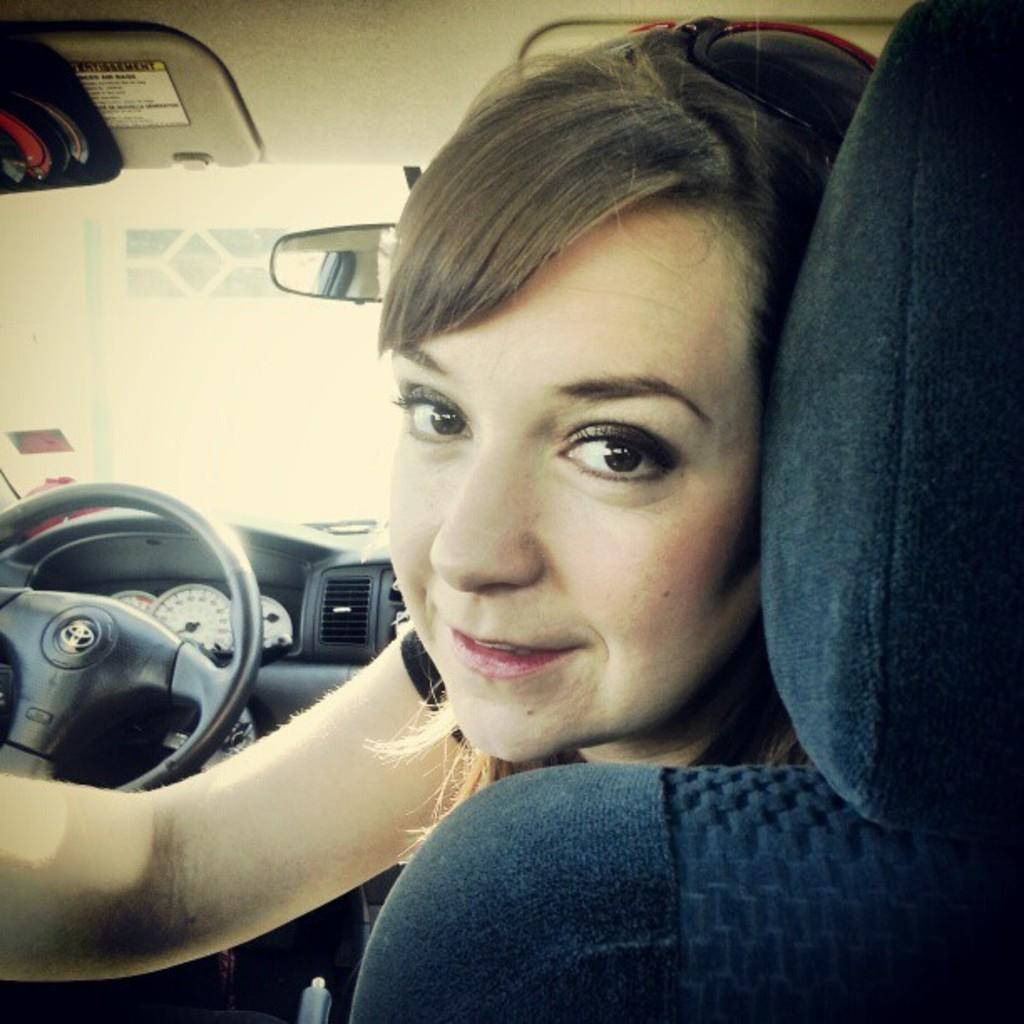Who is present in the image? There is a woman in the image. What is the woman's position in the image? The woman is sitting inside a car. Where is the woman sitting in relation to the driver's seat? The woman is sitting beside the driver's seat. What type of map is the woman holding in the image? There is no map present in the image; the woman is sitting inside a car. What is the woman's reaction to the apparatus in the image? There is no apparatus present in the image, and therefore no reaction can be observed. 